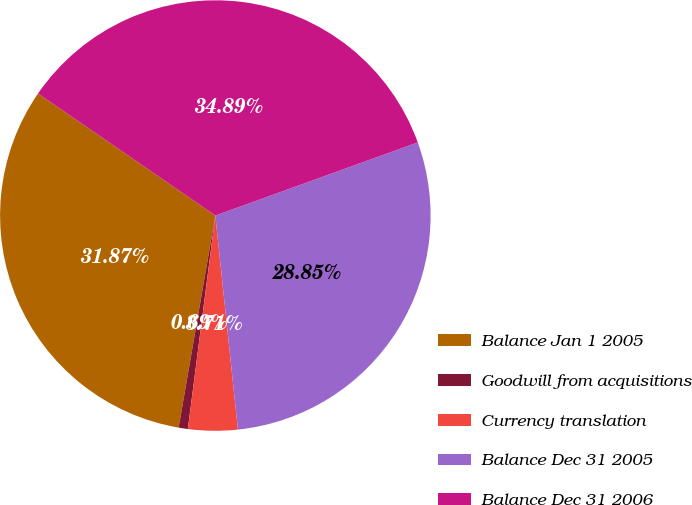Convert chart to OTSL. <chart><loc_0><loc_0><loc_500><loc_500><pie_chart><fcel>Balance Jan 1 2005<fcel>Goodwill from acquisitions<fcel>Currency translation<fcel>Balance Dec 31 2005<fcel>Balance Dec 31 2006<nl><fcel>31.87%<fcel>0.69%<fcel>3.71%<fcel>28.85%<fcel>34.89%<nl></chart> 